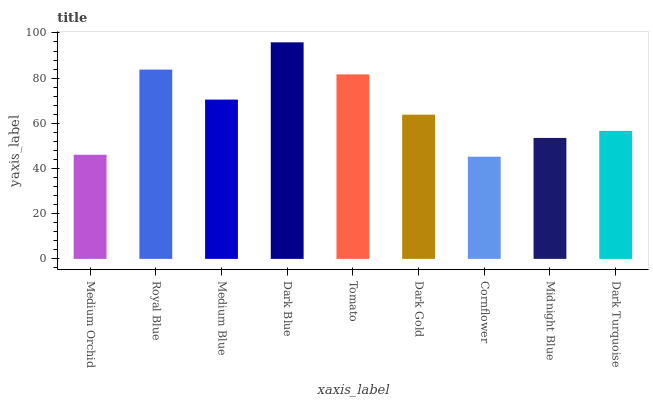Is Cornflower the minimum?
Answer yes or no. Yes. Is Dark Blue the maximum?
Answer yes or no. Yes. Is Royal Blue the minimum?
Answer yes or no. No. Is Royal Blue the maximum?
Answer yes or no. No. Is Royal Blue greater than Medium Orchid?
Answer yes or no. Yes. Is Medium Orchid less than Royal Blue?
Answer yes or no. Yes. Is Medium Orchid greater than Royal Blue?
Answer yes or no. No. Is Royal Blue less than Medium Orchid?
Answer yes or no. No. Is Dark Gold the high median?
Answer yes or no. Yes. Is Dark Gold the low median?
Answer yes or no. Yes. Is Dark Blue the high median?
Answer yes or no. No. Is Cornflower the low median?
Answer yes or no. No. 